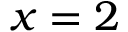<formula> <loc_0><loc_0><loc_500><loc_500>x = 2</formula> 